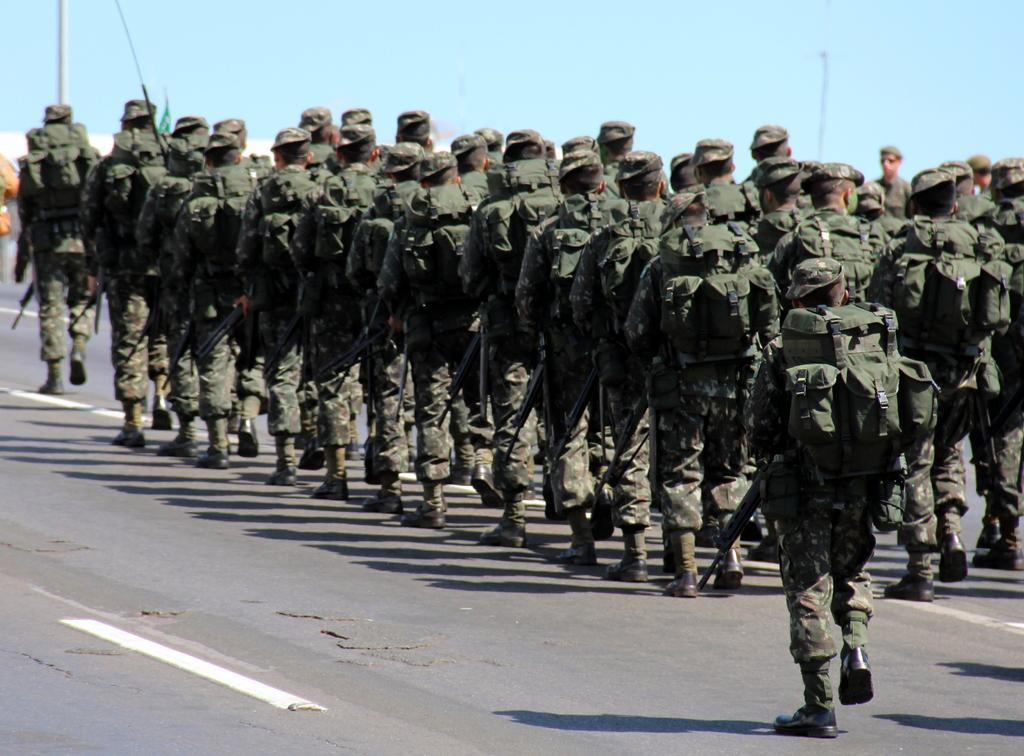Can you describe this image briefly? In this image, we can see some soldiers walking, we can see the road, we can also see the poles and the sky. 